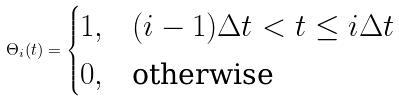<formula> <loc_0><loc_0><loc_500><loc_500>\Theta _ { i } ( t ) = \begin{cases} 1 , & ( i - 1 ) \Delta t < t \leq i \Delta t \\ 0 , & \text {otherwise} \end{cases}</formula> 